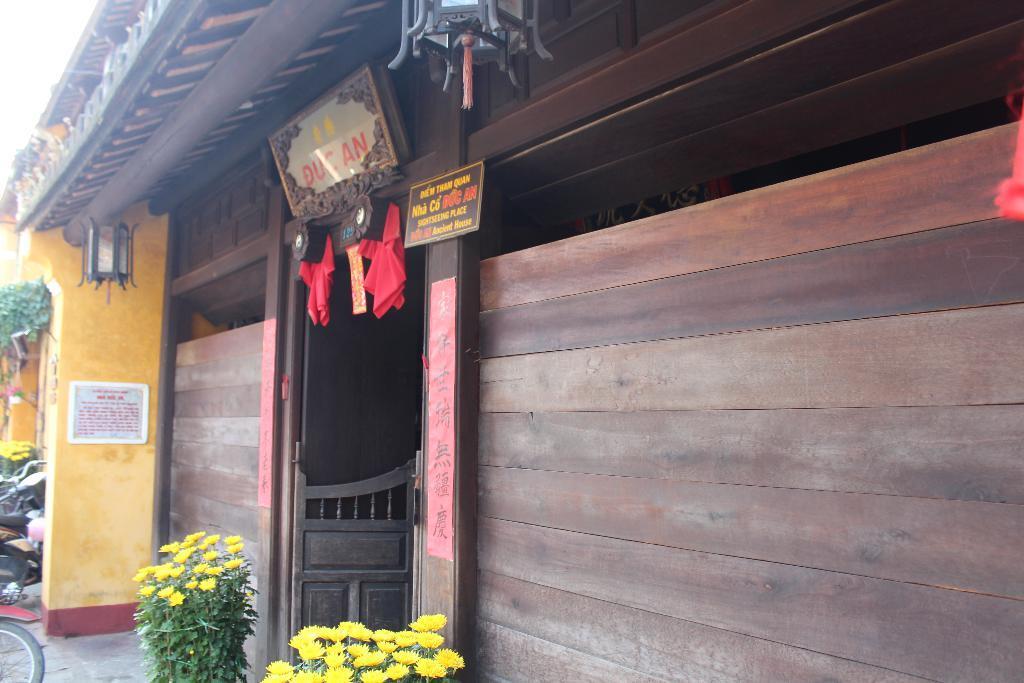How would you summarize this image in a sentence or two? In this image there is a wooden house with lamps, photo frames, name boards on it, in front of the house there is a wooden door, besides the door there are two flower pots with plants, beside the flower pots there is a pillar, in front of the pillar there are bikes parked and there are some other flower pots and plants. 